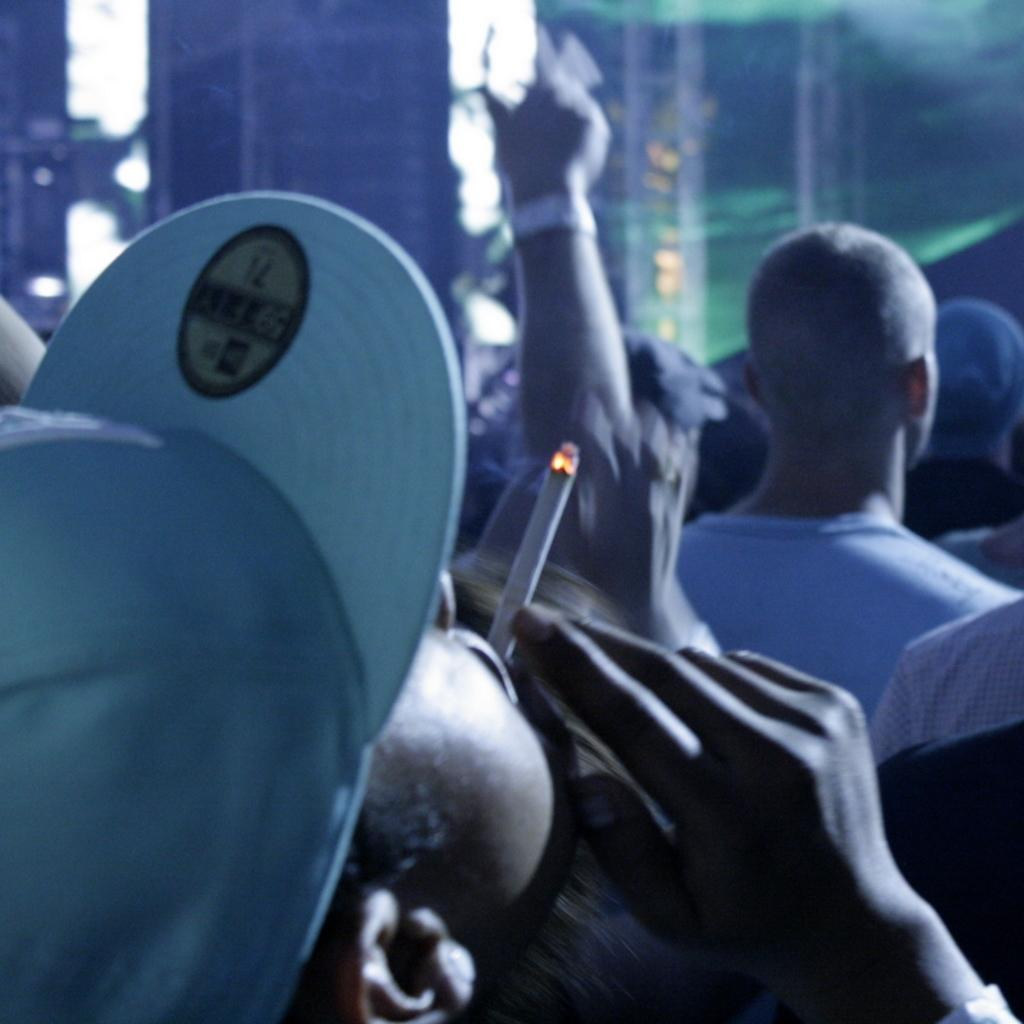What is the main subject of the image? The main subject of the image is a crowd. Can you describe any specific details about the people in the crowd? One person in the crowd is wearing a hat and smoking a cigar. What can be observed about the background of the image? The background of the image is blurred. What type of cabbage is being used as a prop in the image? There is no cabbage present in the image. Can you tell me how much blood is visible in the image? There is no blood visible in the image. 